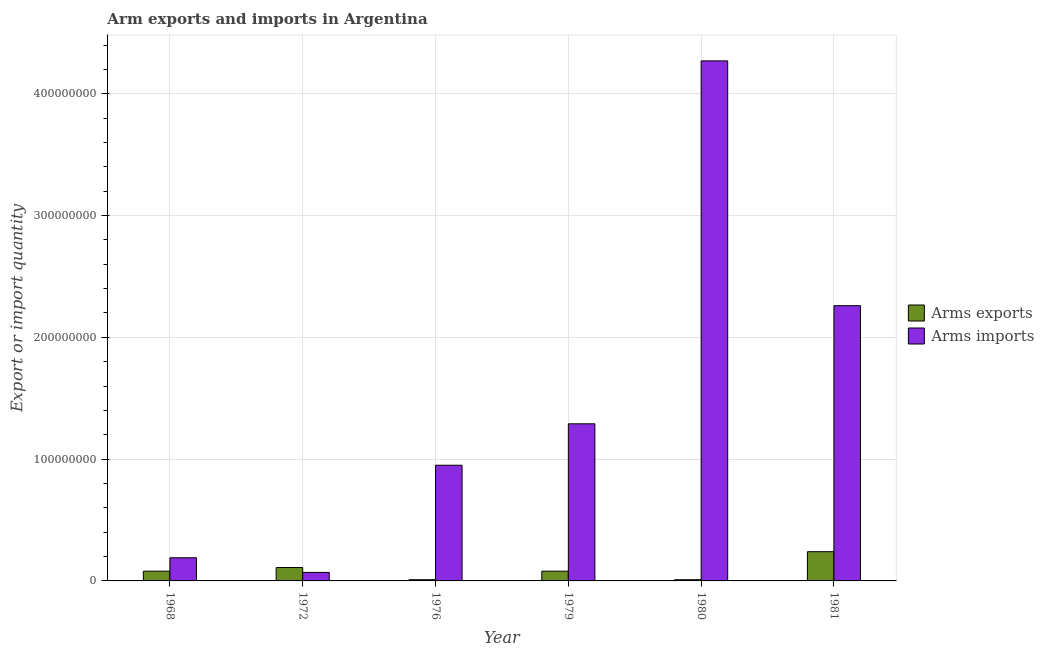Are the number of bars per tick equal to the number of legend labels?
Your answer should be very brief. Yes. What is the label of the 3rd group of bars from the left?
Give a very brief answer. 1976. In how many cases, is the number of bars for a given year not equal to the number of legend labels?
Give a very brief answer. 0. What is the arms imports in 1976?
Offer a terse response. 9.50e+07. Across all years, what is the maximum arms exports?
Keep it short and to the point. 2.40e+07. Across all years, what is the minimum arms exports?
Keep it short and to the point. 1.00e+06. In which year was the arms imports maximum?
Make the answer very short. 1980. In which year was the arms exports minimum?
Offer a very short reply. 1976. What is the total arms exports in the graph?
Your answer should be very brief. 5.30e+07. What is the difference between the arms exports in 1972 and that in 1980?
Your answer should be compact. 1.00e+07. What is the difference between the arms exports in 1976 and the arms imports in 1968?
Your response must be concise. -7.00e+06. What is the average arms exports per year?
Ensure brevity in your answer.  8.83e+06. What is the difference between the highest and the second highest arms imports?
Offer a terse response. 2.01e+08. What is the difference between the highest and the lowest arms imports?
Offer a very short reply. 4.20e+08. In how many years, is the arms imports greater than the average arms imports taken over all years?
Your answer should be compact. 2. What does the 1st bar from the left in 1981 represents?
Your response must be concise. Arms exports. What does the 1st bar from the right in 1980 represents?
Provide a short and direct response. Arms imports. What is the difference between two consecutive major ticks on the Y-axis?
Your response must be concise. 1.00e+08. How many legend labels are there?
Offer a terse response. 2. How are the legend labels stacked?
Offer a very short reply. Vertical. What is the title of the graph?
Make the answer very short. Arm exports and imports in Argentina. What is the label or title of the Y-axis?
Provide a succinct answer. Export or import quantity. What is the Export or import quantity of Arms exports in 1968?
Offer a terse response. 8.00e+06. What is the Export or import quantity in Arms imports in 1968?
Make the answer very short. 1.90e+07. What is the Export or import quantity of Arms exports in 1972?
Keep it short and to the point. 1.10e+07. What is the Export or import quantity in Arms exports in 1976?
Give a very brief answer. 1.00e+06. What is the Export or import quantity of Arms imports in 1976?
Your answer should be very brief. 9.50e+07. What is the Export or import quantity of Arms exports in 1979?
Ensure brevity in your answer.  8.00e+06. What is the Export or import quantity of Arms imports in 1979?
Your answer should be compact. 1.29e+08. What is the Export or import quantity of Arms exports in 1980?
Give a very brief answer. 1.00e+06. What is the Export or import quantity of Arms imports in 1980?
Provide a short and direct response. 4.27e+08. What is the Export or import quantity in Arms exports in 1981?
Your answer should be very brief. 2.40e+07. What is the Export or import quantity of Arms imports in 1981?
Offer a very short reply. 2.26e+08. Across all years, what is the maximum Export or import quantity of Arms exports?
Provide a short and direct response. 2.40e+07. Across all years, what is the maximum Export or import quantity in Arms imports?
Your response must be concise. 4.27e+08. Across all years, what is the minimum Export or import quantity in Arms exports?
Provide a succinct answer. 1.00e+06. What is the total Export or import quantity in Arms exports in the graph?
Your response must be concise. 5.30e+07. What is the total Export or import quantity in Arms imports in the graph?
Offer a very short reply. 9.03e+08. What is the difference between the Export or import quantity of Arms exports in 1968 and that in 1976?
Your answer should be compact. 7.00e+06. What is the difference between the Export or import quantity of Arms imports in 1968 and that in 1976?
Provide a succinct answer. -7.60e+07. What is the difference between the Export or import quantity of Arms imports in 1968 and that in 1979?
Your answer should be very brief. -1.10e+08. What is the difference between the Export or import quantity in Arms exports in 1968 and that in 1980?
Provide a succinct answer. 7.00e+06. What is the difference between the Export or import quantity in Arms imports in 1968 and that in 1980?
Your answer should be compact. -4.08e+08. What is the difference between the Export or import quantity of Arms exports in 1968 and that in 1981?
Your answer should be compact. -1.60e+07. What is the difference between the Export or import quantity of Arms imports in 1968 and that in 1981?
Give a very brief answer. -2.07e+08. What is the difference between the Export or import quantity in Arms exports in 1972 and that in 1976?
Make the answer very short. 1.00e+07. What is the difference between the Export or import quantity in Arms imports in 1972 and that in 1976?
Provide a short and direct response. -8.80e+07. What is the difference between the Export or import quantity of Arms exports in 1972 and that in 1979?
Provide a succinct answer. 3.00e+06. What is the difference between the Export or import quantity of Arms imports in 1972 and that in 1979?
Provide a short and direct response. -1.22e+08. What is the difference between the Export or import quantity of Arms exports in 1972 and that in 1980?
Your answer should be compact. 1.00e+07. What is the difference between the Export or import quantity in Arms imports in 1972 and that in 1980?
Provide a short and direct response. -4.20e+08. What is the difference between the Export or import quantity in Arms exports in 1972 and that in 1981?
Give a very brief answer. -1.30e+07. What is the difference between the Export or import quantity of Arms imports in 1972 and that in 1981?
Your answer should be very brief. -2.19e+08. What is the difference between the Export or import quantity in Arms exports in 1976 and that in 1979?
Offer a terse response. -7.00e+06. What is the difference between the Export or import quantity of Arms imports in 1976 and that in 1979?
Your answer should be compact. -3.40e+07. What is the difference between the Export or import quantity in Arms exports in 1976 and that in 1980?
Provide a succinct answer. 0. What is the difference between the Export or import quantity in Arms imports in 1976 and that in 1980?
Provide a short and direct response. -3.32e+08. What is the difference between the Export or import quantity of Arms exports in 1976 and that in 1981?
Ensure brevity in your answer.  -2.30e+07. What is the difference between the Export or import quantity of Arms imports in 1976 and that in 1981?
Give a very brief answer. -1.31e+08. What is the difference between the Export or import quantity of Arms imports in 1979 and that in 1980?
Your answer should be compact. -2.98e+08. What is the difference between the Export or import quantity of Arms exports in 1979 and that in 1981?
Your response must be concise. -1.60e+07. What is the difference between the Export or import quantity of Arms imports in 1979 and that in 1981?
Your answer should be very brief. -9.70e+07. What is the difference between the Export or import quantity of Arms exports in 1980 and that in 1981?
Make the answer very short. -2.30e+07. What is the difference between the Export or import quantity in Arms imports in 1980 and that in 1981?
Provide a succinct answer. 2.01e+08. What is the difference between the Export or import quantity in Arms exports in 1968 and the Export or import quantity in Arms imports in 1976?
Offer a terse response. -8.70e+07. What is the difference between the Export or import quantity of Arms exports in 1968 and the Export or import quantity of Arms imports in 1979?
Your answer should be very brief. -1.21e+08. What is the difference between the Export or import quantity in Arms exports in 1968 and the Export or import quantity in Arms imports in 1980?
Offer a terse response. -4.19e+08. What is the difference between the Export or import quantity in Arms exports in 1968 and the Export or import quantity in Arms imports in 1981?
Keep it short and to the point. -2.18e+08. What is the difference between the Export or import quantity in Arms exports in 1972 and the Export or import quantity in Arms imports in 1976?
Offer a very short reply. -8.40e+07. What is the difference between the Export or import quantity of Arms exports in 1972 and the Export or import quantity of Arms imports in 1979?
Offer a very short reply. -1.18e+08. What is the difference between the Export or import quantity in Arms exports in 1972 and the Export or import quantity in Arms imports in 1980?
Your answer should be compact. -4.16e+08. What is the difference between the Export or import quantity of Arms exports in 1972 and the Export or import quantity of Arms imports in 1981?
Ensure brevity in your answer.  -2.15e+08. What is the difference between the Export or import quantity of Arms exports in 1976 and the Export or import quantity of Arms imports in 1979?
Your answer should be compact. -1.28e+08. What is the difference between the Export or import quantity of Arms exports in 1976 and the Export or import quantity of Arms imports in 1980?
Your answer should be very brief. -4.26e+08. What is the difference between the Export or import quantity of Arms exports in 1976 and the Export or import quantity of Arms imports in 1981?
Provide a succinct answer. -2.25e+08. What is the difference between the Export or import quantity of Arms exports in 1979 and the Export or import quantity of Arms imports in 1980?
Your answer should be very brief. -4.19e+08. What is the difference between the Export or import quantity of Arms exports in 1979 and the Export or import quantity of Arms imports in 1981?
Your response must be concise. -2.18e+08. What is the difference between the Export or import quantity in Arms exports in 1980 and the Export or import quantity in Arms imports in 1981?
Keep it short and to the point. -2.25e+08. What is the average Export or import quantity of Arms exports per year?
Provide a succinct answer. 8.83e+06. What is the average Export or import quantity in Arms imports per year?
Give a very brief answer. 1.50e+08. In the year 1968, what is the difference between the Export or import quantity of Arms exports and Export or import quantity of Arms imports?
Your response must be concise. -1.10e+07. In the year 1972, what is the difference between the Export or import quantity in Arms exports and Export or import quantity in Arms imports?
Provide a succinct answer. 4.00e+06. In the year 1976, what is the difference between the Export or import quantity of Arms exports and Export or import quantity of Arms imports?
Keep it short and to the point. -9.40e+07. In the year 1979, what is the difference between the Export or import quantity in Arms exports and Export or import quantity in Arms imports?
Provide a succinct answer. -1.21e+08. In the year 1980, what is the difference between the Export or import quantity in Arms exports and Export or import quantity in Arms imports?
Provide a succinct answer. -4.26e+08. In the year 1981, what is the difference between the Export or import quantity of Arms exports and Export or import quantity of Arms imports?
Keep it short and to the point. -2.02e+08. What is the ratio of the Export or import quantity of Arms exports in 1968 to that in 1972?
Offer a very short reply. 0.73. What is the ratio of the Export or import quantity in Arms imports in 1968 to that in 1972?
Offer a very short reply. 2.71. What is the ratio of the Export or import quantity in Arms exports in 1968 to that in 1976?
Provide a succinct answer. 8. What is the ratio of the Export or import quantity of Arms imports in 1968 to that in 1976?
Provide a succinct answer. 0.2. What is the ratio of the Export or import quantity of Arms exports in 1968 to that in 1979?
Offer a terse response. 1. What is the ratio of the Export or import quantity of Arms imports in 1968 to that in 1979?
Give a very brief answer. 0.15. What is the ratio of the Export or import quantity in Arms imports in 1968 to that in 1980?
Provide a succinct answer. 0.04. What is the ratio of the Export or import quantity in Arms exports in 1968 to that in 1981?
Keep it short and to the point. 0.33. What is the ratio of the Export or import quantity in Arms imports in 1968 to that in 1981?
Keep it short and to the point. 0.08. What is the ratio of the Export or import quantity of Arms exports in 1972 to that in 1976?
Offer a very short reply. 11. What is the ratio of the Export or import quantity of Arms imports in 1972 to that in 1976?
Give a very brief answer. 0.07. What is the ratio of the Export or import quantity in Arms exports in 1972 to that in 1979?
Your response must be concise. 1.38. What is the ratio of the Export or import quantity in Arms imports in 1972 to that in 1979?
Make the answer very short. 0.05. What is the ratio of the Export or import quantity in Arms exports in 1972 to that in 1980?
Provide a succinct answer. 11. What is the ratio of the Export or import quantity of Arms imports in 1972 to that in 1980?
Provide a succinct answer. 0.02. What is the ratio of the Export or import quantity of Arms exports in 1972 to that in 1981?
Keep it short and to the point. 0.46. What is the ratio of the Export or import quantity of Arms imports in 1972 to that in 1981?
Make the answer very short. 0.03. What is the ratio of the Export or import quantity in Arms exports in 1976 to that in 1979?
Your answer should be compact. 0.12. What is the ratio of the Export or import quantity of Arms imports in 1976 to that in 1979?
Make the answer very short. 0.74. What is the ratio of the Export or import quantity of Arms exports in 1976 to that in 1980?
Keep it short and to the point. 1. What is the ratio of the Export or import quantity of Arms imports in 1976 to that in 1980?
Ensure brevity in your answer.  0.22. What is the ratio of the Export or import quantity in Arms exports in 1976 to that in 1981?
Make the answer very short. 0.04. What is the ratio of the Export or import quantity of Arms imports in 1976 to that in 1981?
Keep it short and to the point. 0.42. What is the ratio of the Export or import quantity in Arms exports in 1979 to that in 1980?
Your answer should be very brief. 8. What is the ratio of the Export or import quantity in Arms imports in 1979 to that in 1980?
Provide a short and direct response. 0.3. What is the ratio of the Export or import quantity of Arms imports in 1979 to that in 1981?
Your answer should be compact. 0.57. What is the ratio of the Export or import quantity of Arms exports in 1980 to that in 1981?
Offer a very short reply. 0.04. What is the ratio of the Export or import quantity in Arms imports in 1980 to that in 1981?
Provide a succinct answer. 1.89. What is the difference between the highest and the second highest Export or import quantity of Arms exports?
Your response must be concise. 1.30e+07. What is the difference between the highest and the second highest Export or import quantity in Arms imports?
Ensure brevity in your answer.  2.01e+08. What is the difference between the highest and the lowest Export or import quantity in Arms exports?
Your answer should be very brief. 2.30e+07. What is the difference between the highest and the lowest Export or import quantity in Arms imports?
Your answer should be compact. 4.20e+08. 